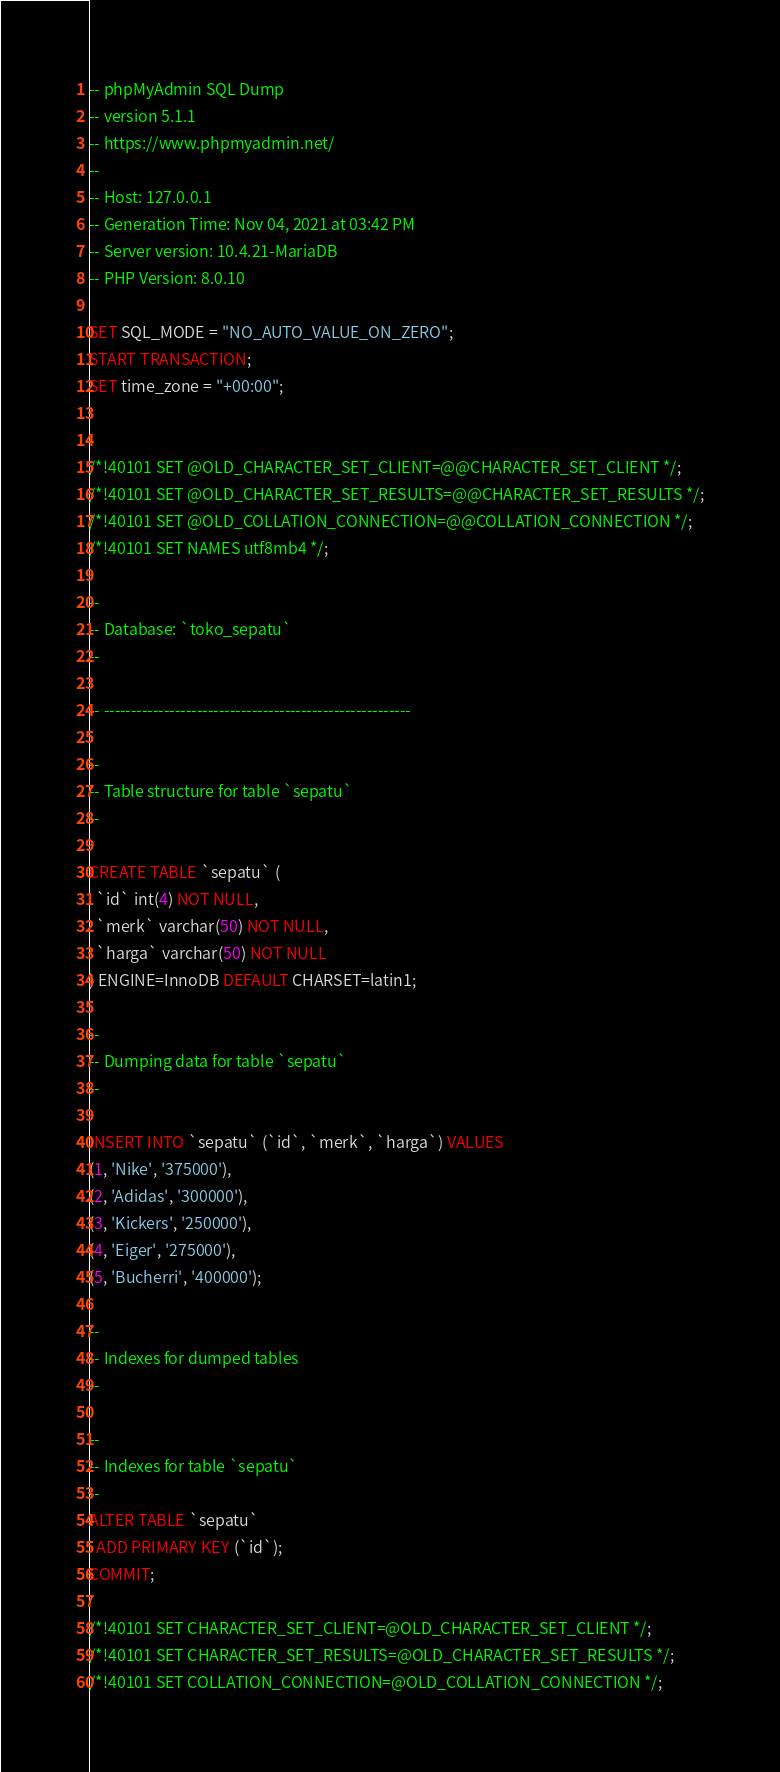Convert code to text. <code><loc_0><loc_0><loc_500><loc_500><_SQL_>-- phpMyAdmin SQL Dump
-- version 5.1.1
-- https://www.phpmyadmin.net/
--
-- Host: 127.0.0.1
-- Generation Time: Nov 04, 2021 at 03:42 PM
-- Server version: 10.4.21-MariaDB
-- PHP Version: 8.0.10

SET SQL_MODE = "NO_AUTO_VALUE_ON_ZERO";
START TRANSACTION;
SET time_zone = "+00:00";


/*!40101 SET @OLD_CHARACTER_SET_CLIENT=@@CHARACTER_SET_CLIENT */;
/*!40101 SET @OLD_CHARACTER_SET_RESULTS=@@CHARACTER_SET_RESULTS */;
/*!40101 SET @OLD_COLLATION_CONNECTION=@@COLLATION_CONNECTION */;
/*!40101 SET NAMES utf8mb4 */;

--
-- Database: `toko_sepatu`
--

-- --------------------------------------------------------

--
-- Table structure for table `sepatu`
--

CREATE TABLE `sepatu` (
  `id` int(4) NOT NULL,
  `merk` varchar(50) NOT NULL,
  `harga` varchar(50) NOT NULL
) ENGINE=InnoDB DEFAULT CHARSET=latin1;

--
-- Dumping data for table `sepatu`
--

INSERT INTO `sepatu` (`id`, `merk`, `harga`) VALUES
(1, 'Nike', '375000'),
(2, 'Adidas', '300000'),
(3, 'Kickers', '250000'),
(4, 'Eiger', '275000'),
(5, 'Bucherri', '400000');

--
-- Indexes for dumped tables
--

--
-- Indexes for table `sepatu`
--
ALTER TABLE `sepatu`
  ADD PRIMARY KEY (`id`);
COMMIT;

/*!40101 SET CHARACTER_SET_CLIENT=@OLD_CHARACTER_SET_CLIENT */;
/*!40101 SET CHARACTER_SET_RESULTS=@OLD_CHARACTER_SET_RESULTS */;
/*!40101 SET COLLATION_CONNECTION=@OLD_COLLATION_CONNECTION */;
</code> 